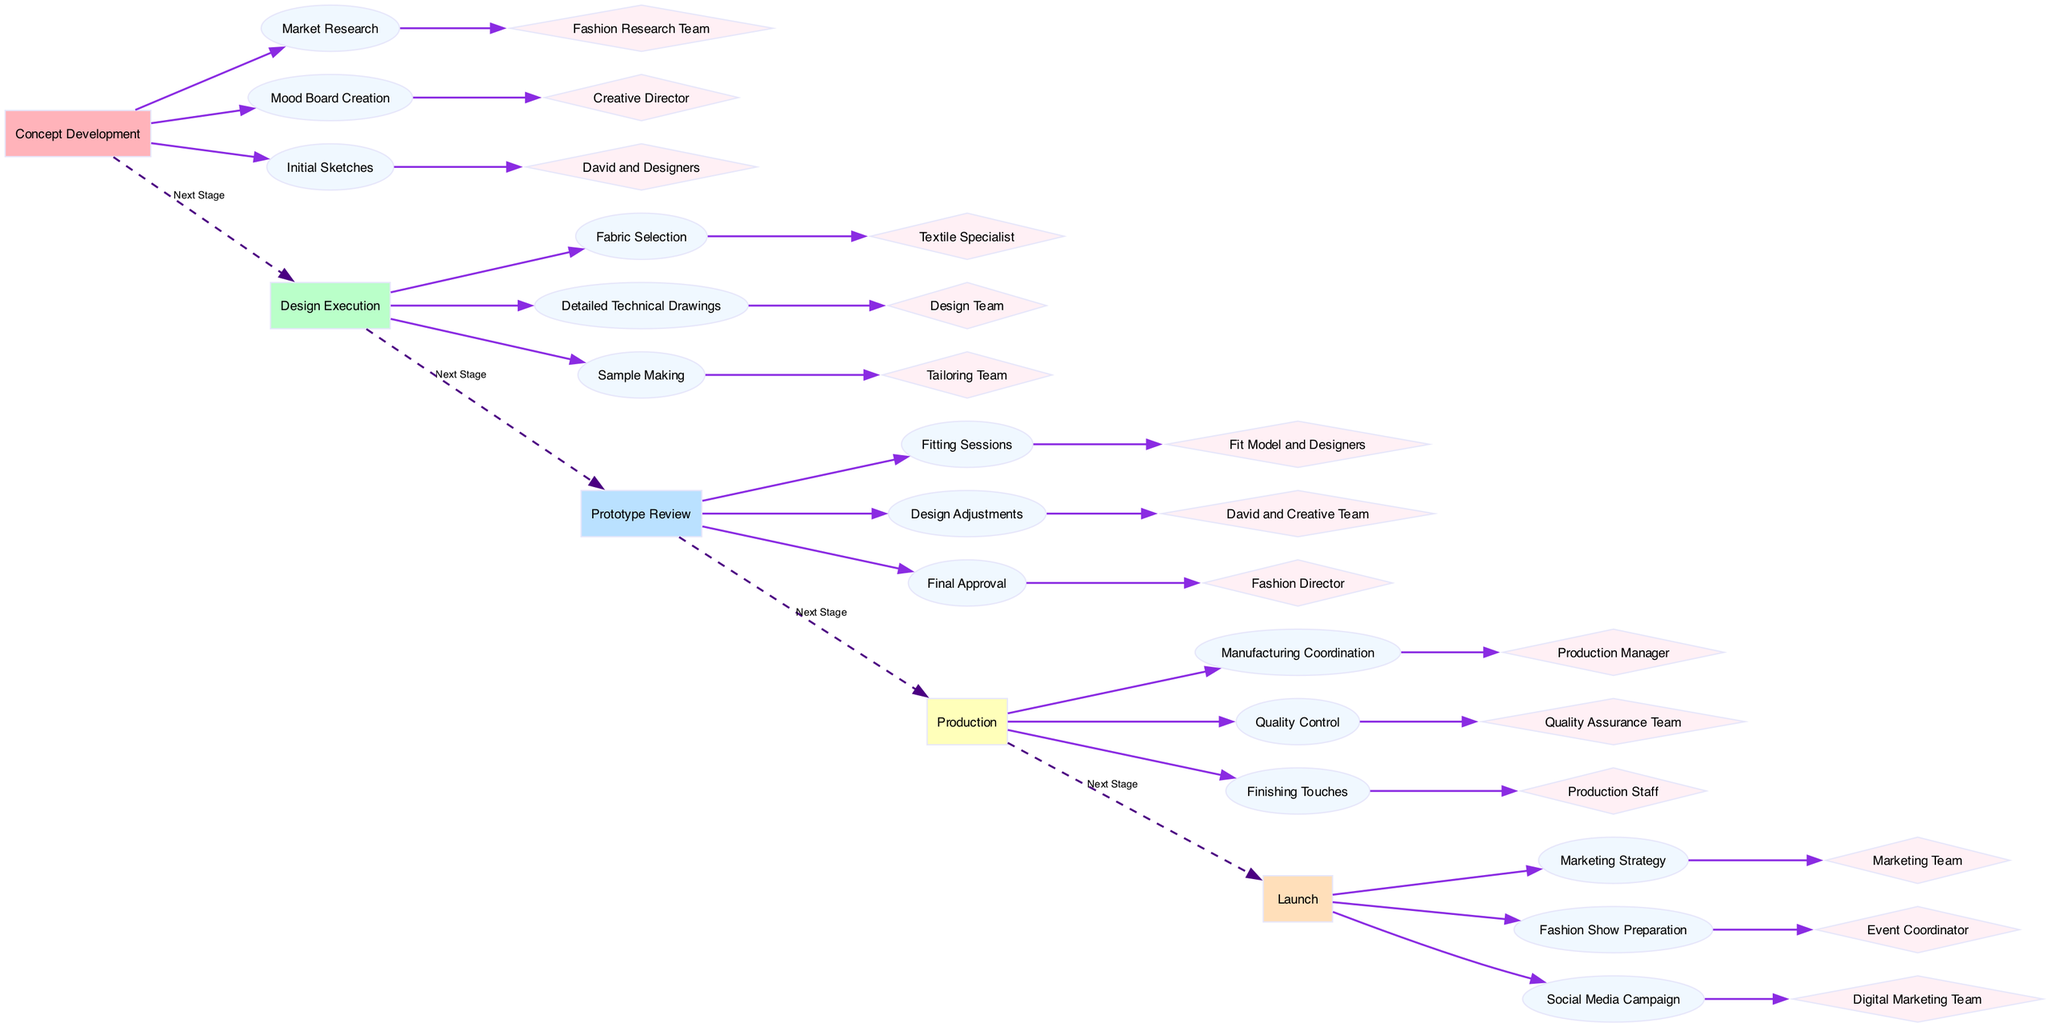What are the stages of the fashion design project? The diagram clearly lists five stages: Concept Development, Design Execution, Prototype Review, Production, and Launch. These are indicated as nodes in the diagram.
Answer: Concept Development, Design Execution, Prototype Review, Production, Launch Who is responsible for Fabric Selection? In the Design Execution stage, the task of Fabric Selection is attributed to the Textile Specialist, shown as a contributor node linked to the task node.
Answer: Textile Specialist How many tasks are involved in Prototype Review? The Prototype Review stage contains three tasks: Fitting Sessions, Design Adjustments, and Final Approval. Counting these tasks gives a total of three.
Answer: 3 What is the final stage before Launch? The last stage before the Launch stage is the Production stage. This is indicated by the dashed edges connecting the stages in the diagram.
Answer: Production Which team is involved in Design Adjustments? The Design Adjustments task in the Prototype Review stage is contributed by David and the Creative Team, as shown in the diagram.
Answer: David and Creative Team Which contributor is linked to Marketing Strategy? The contributor for the Marketing Strategy task in the Launch stage is the Marketing Team, clearly indicated at the end of the task node.
Answer: Marketing Team How many edges connect the stages? There are four dashed edges connecting the five stages of the project, indicating the transitions between each stage.
Answer: 4 What type of tasks does the Tailoring Team perform? The Tailoring Team is responsible for the Sample Making task in the Design Execution stage, which is specified as a task node connected to their contributor node.
Answer: Sample Making Which contributor is responsible for Finishing Touches? The Finishing Touches task in the Production stage is attributed to the Production Staff, shown in the diagram as the contributor for this task.
Answer: Production Staff 